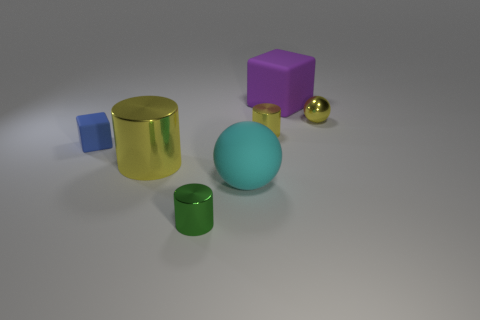What number of large rubber objects have the same color as the tiny ball?
Give a very brief answer. 0. There is a tiny yellow object on the left side of the tiny yellow metallic thing right of the big cube; what is it made of?
Offer a terse response. Metal. The green metallic object is what size?
Offer a very short reply. Small. How many green metal cylinders have the same size as the metallic sphere?
Give a very brief answer. 1. How many other yellow things are the same shape as the big yellow thing?
Your answer should be compact. 1. Are there an equal number of big purple things to the right of the big purple matte block and tiny blue cubes?
Make the answer very short. No. Are there any other things that have the same size as the cyan sphere?
Provide a succinct answer. Yes. There is a yellow shiny thing that is the same size as the purple cube; what is its shape?
Your answer should be compact. Cylinder. Is there another small thing that has the same shape as the small blue rubber thing?
Make the answer very short. No. There is a large purple thing behind the rubber object in front of the tiny rubber thing; are there any cylinders behind it?
Offer a very short reply. No. 